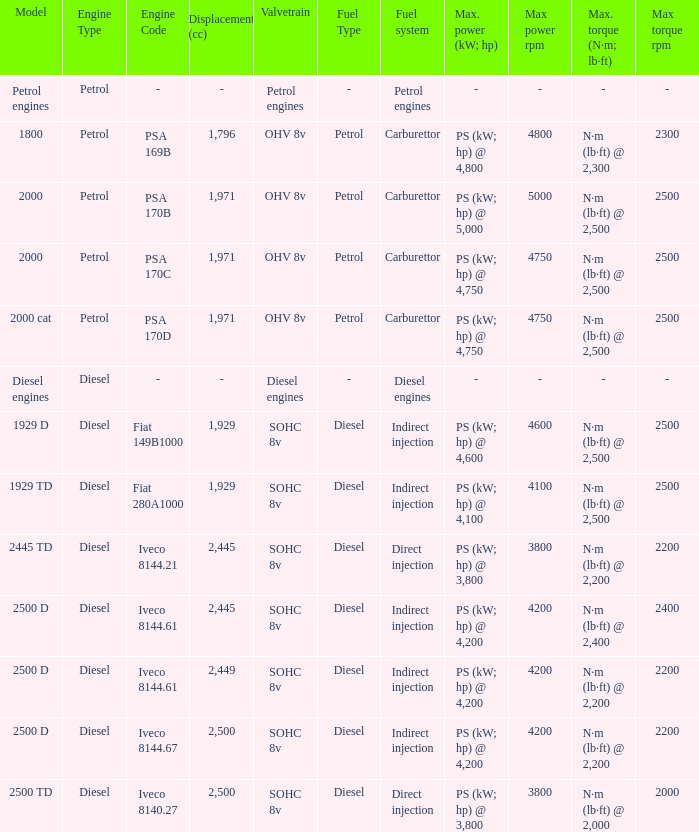What is the peak torque for a 2,445 cc displacement and an iveco 814 N·m (lb·ft) @ 2,400 rpm. 